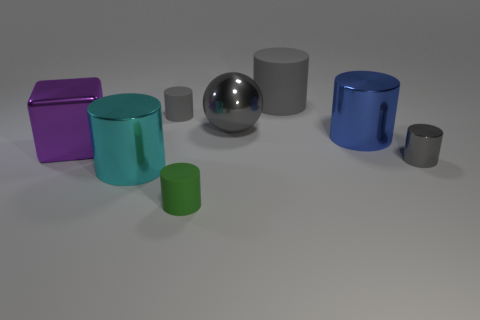How many gray cylinders must be subtracted to get 1 gray cylinders? 2 Subtract all gray metallic cylinders. How many cylinders are left? 5 Subtract all cubes. How many objects are left? 7 Add 1 large balls. How many objects exist? 9 Subtract all gray cylinders. How many cylinders are left? 3 Subtract 1 cubes. How many cubes are left? 0 Subtract all large brown metallic objects. Subtract all small rubber cylinders. How many objects are left? 6 Add 2 large objects. How many large objects are left? 7 Add 3 big red metallic cylinders. How many big red metallic cylinders exist? 3 Subtract 1 blue cylinders. How many objects are left? 7 